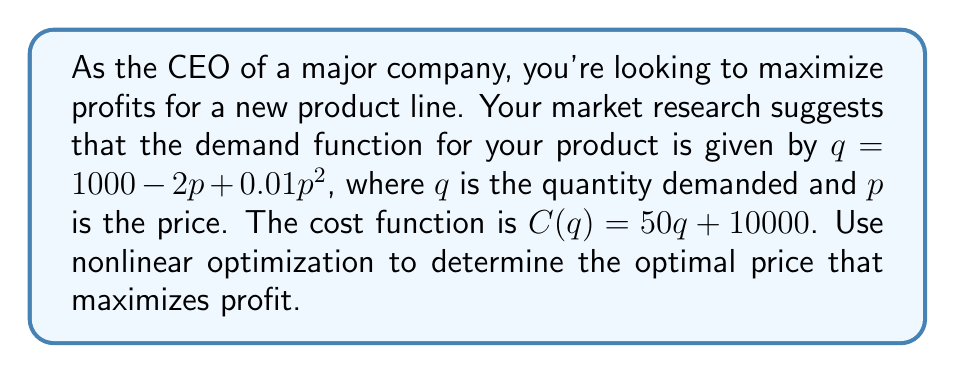Help me with this question. 1) First, we need to formulate the profit function:
   Profit = Revenue - Cost
   $\pi(p) = pq - C(q)$

2) Substitute the demand function into the profit equation:
   $\pi(p) = p(1000 - 2p + 0.01p^2) - [50(1000 - 2p + 0.01p^2) + 10000]$

3) Expand the equation:
   $\pi(p) = 1000p - 2p^2 + 0.01p^3 - 50000 + 100p - 0.5p^2 - 10000$
   $\pi(p) = 0.01p^3 - 2.5p^2 + 1100p - 60000$

4) To find the maximum profit, we need to find where the derivative of the profit function equals zero:
   $\frac{d\pi}{dp} = 0.03p^2 - 5p + 1100 = 0$

5) This is a quadratic equation. We can solve it using the quadratic formula:
   $p = \frac{-b \pm \sqrt{b^2 - 4ac}}{2a}$

   Where $a = 0.03$, $b = -5$, and $c = 1100$

6) Solving:
   $p = \frac{5 \pm \sqrt{25 - 4(0.03)(1100)}}{2(0.03)}$
   $p = \frac{5 \pm \sqrt{-107}}{0.06}$

7) Since we can't have an imaginary price, we need to consider the second derivative to find the maximum:
   $\frac{d^2\pi}{dp^2} = 0.06p - 5$

8) Setting this equal to zero:
   $0.06p - 5 = 0$
   $p = \frac{5}{0.06} \approx 83.33$

9) Verify this is a maximum by checking if the second derivative is negative at this point:
   $\frac{d^2\pi}{dp^2}|_{p=83.33} = 0.06(83.33) - 5 = 0 < 0$

10) Therefore, the optimal price is approximately $83.33.
Answer: $83.33 